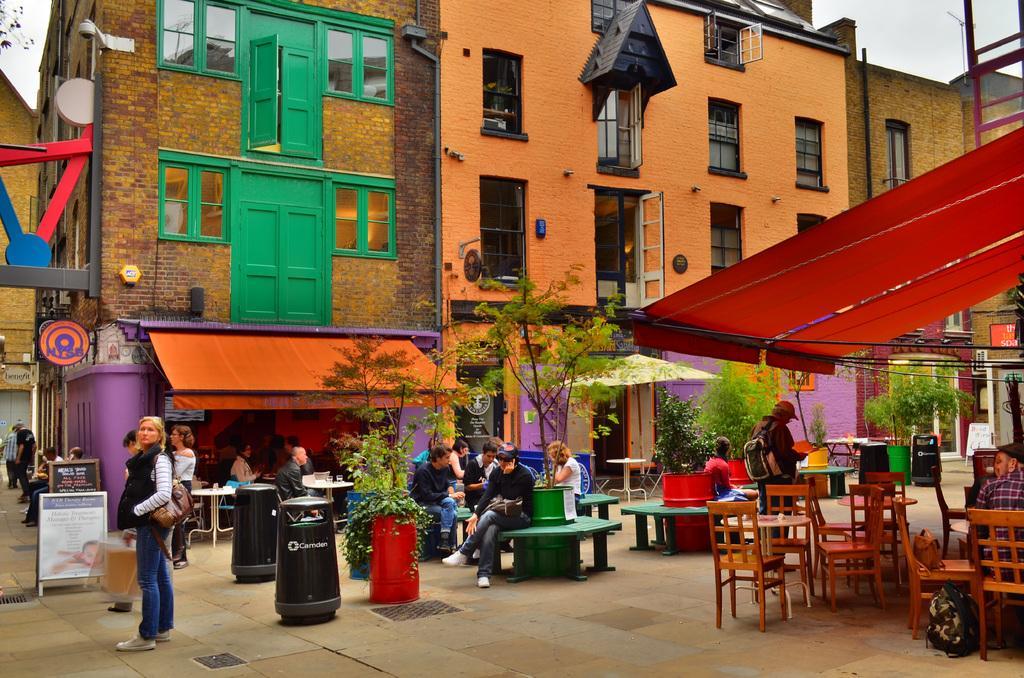Could you give a brief overview of what you see in this image? There are some plants, tables, chairs, trees here and some of the people are sitting on the table. Some of them are standing. In the background, there are some buildings with some windows and a sky here. 